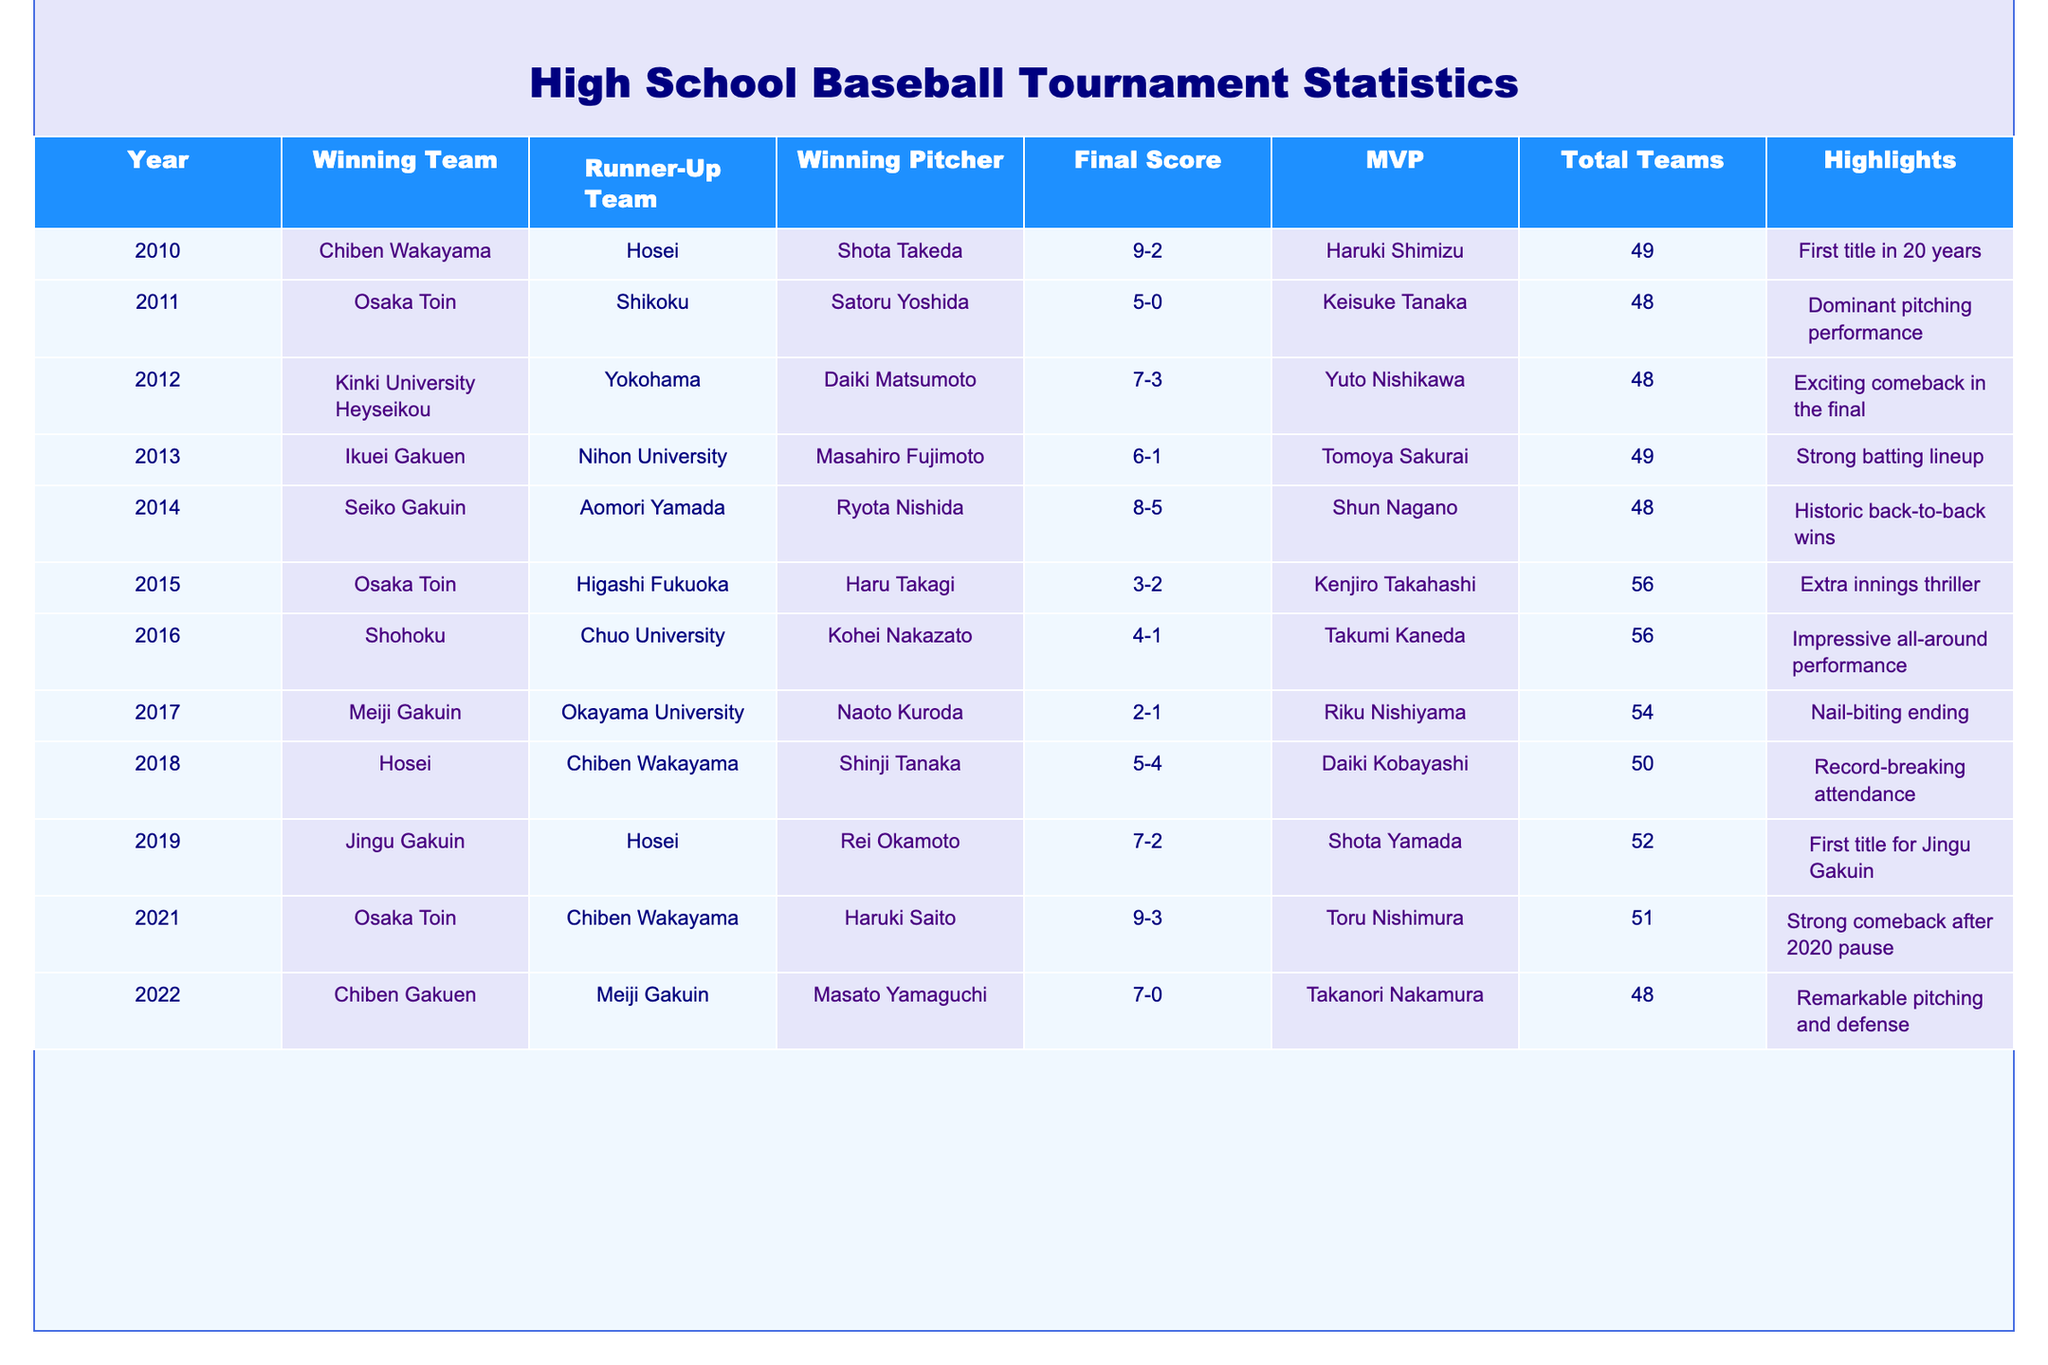What year did Chiben Wakayama win the championship? Chiben Wakayama won the championship in 2010 and 2018, as indicated by their entries in the Winning Team column for those years.
Answer: 2010 and 2018 Which team had the highest final score recorded? The highest final score recorded is 9-3 for Osaka Toin in 2021, as seen in the Final Score column, where the highest score is 9 in that match.
Answer: Osaka Toin in 2021 How many times did Osaka Toin win the tournament? Osaka Toin won the tournament three times, in 2011, 2015, and 2021, counting the rows where Osaka Toin appears in the Winning Team column.
Answer: Three times Was there a year when the final score was 7-0? Yes, the final score was 7-0 in the year 2022, corresponding to the entry for Chiben Gakuen in that year.
Answer: Yes Which winning team had the MVP with the first name "Kenjiro"? The winning team that had the MVP with the first name "Kenjiro" is Osaka Toin in 2015, as identified in the MVP column for that year.
Answer: Osaka Toin in 2015 What is the average number of teams participating in the tournaments for the years listed? To find the average, sum the total number of teams (49 + 48 + 48 + 49 + 48 + 56 + 56 + 54 + 50 + 52 + 51 + 48) = 636, and count the number of years (12), giving an average of 636 / 12 = 53.
Answer: 53 Which team was the runner-up most frequently? The team that was the runner-up most frequently is Hosei, finishing as the runner-up in 2011, 2018, and 2019, making a total of three appearances in the Runner-Up Team column.
Answer: Hosei In which year did a team score 5 runs in the final match? A team scored 5 runs in the finals during the years 2018 and 2010, as reflected in the Final Score column with scores of 5-4 and 9-2 respectively.
Answer: 2010 and 2018 Are there any highlighted events that pertain to back-to-back wins? Yes, the event highlighted as a "Historic back-to-back wins" occurred in 2014 for Seiko Gakuin.
Answer: Yes 